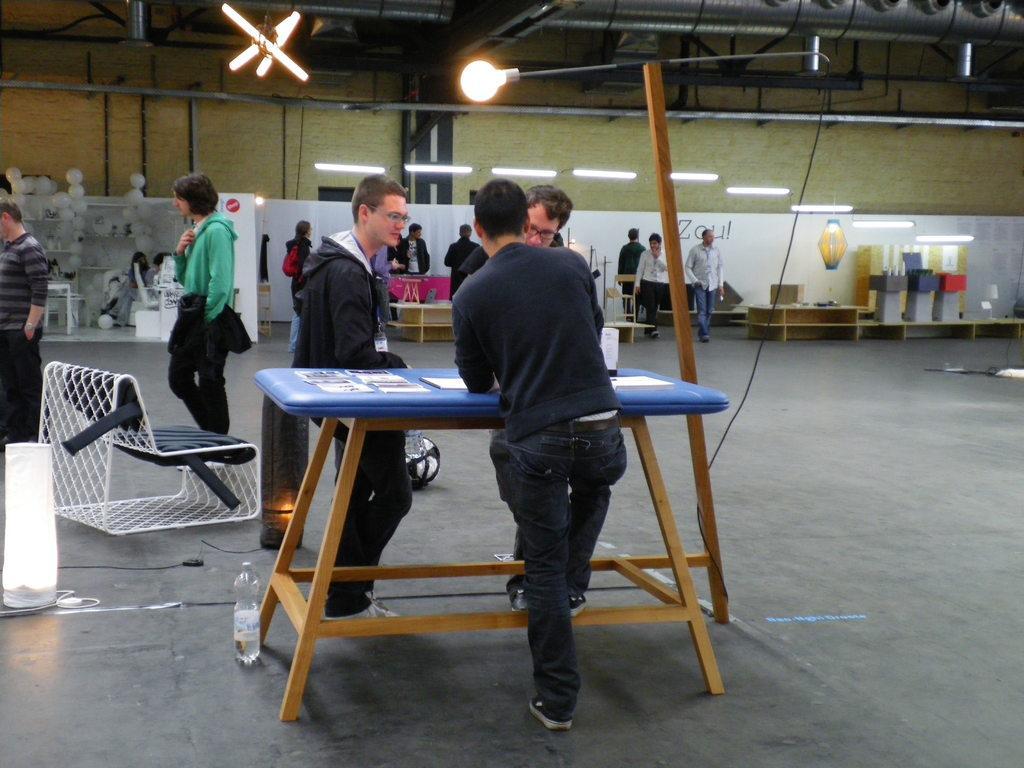In one or two sentences, can you explain what this image depicts? In this picture there is a blue table with some papers on it. Around the table there are three men standing. They are wearing black jackets. To the left corner there is a man standing. And in the background there are some cupboards, balloons. And a man with green jacket is standing. In the background there are some people walking. 